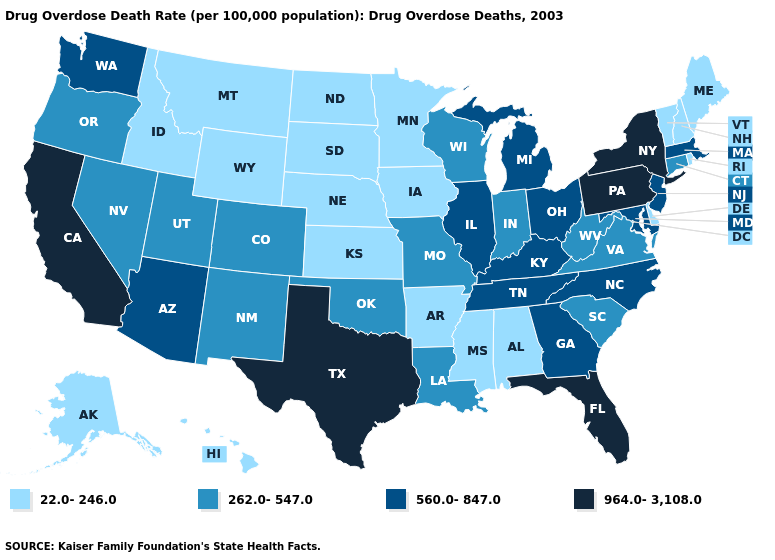Which states have the lowest value in the South?
Keep it brief. Alabama, Arkansas, Delaware, Mississippi. What is the value of Texas?
Answer briefly. 964.0-3,108.0. Does the map have missing data?
Give a very brief answer. No. Does Alabama have the lowest value in the South?
Short answer required. Yes. What is the value of Wyoming?
Answer briefly. 22.0-246.0. What is the value of Vermont?
Give a very brief answer. 22.0-246.0. Does South Carolina have the lowest value in the USA?
Be succinct. No. What is the value of Nevada?
Answer briefly. 262.0-547.0. Name the states that have a value in the range 22.0-246.0?
Keep it brief. Alabama, Alaska, Arkansas, Delaware, Hawaii, Idaho, Iowa, Kansas, Maine, Minnesota, Mississippi, Montana, Nebraska, New Hampshire, North Dakota, Rhode Island, South Dakota, Vermont, Wyoming. What is the value of Alaska?
Keep it brief. 22.0-246.0. Does Florida have the highest value in the South?
Concise answer only. Yes. What is the lowest value in the West?
Give a very brief answer. 22.0-246.0. Is the legend a continuous bar?
Quick response, please. No. What is the lowest value in states that border New York?
Keep it brief. 22.0-246.0. What is the highest value in states that border Louisiana?
Concise answer only. 964.0-3,108.0. 